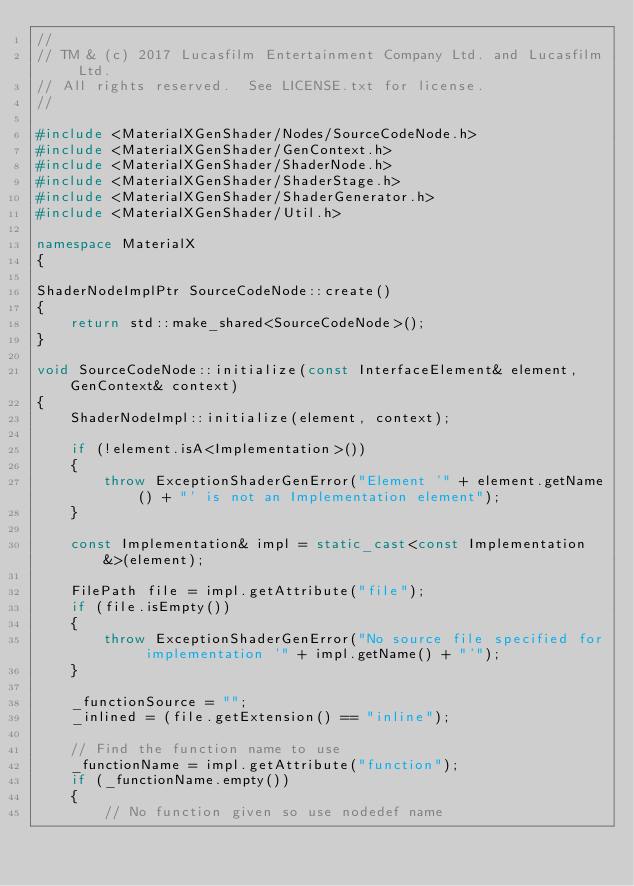<code> <loc_0><loc_0><loc_500><loc_500><_C++_>//
// TM & (c) 2017 Lucasfilm Entertainment Company Ltd. and Lucasfilm Ltd.
// All rights reserved.  See LICENSE.txt for license.
//

#include <MaterialXGenShader/Nodes/SourceCodeNode.h>
#include <MaterialXGenShader/GenContext.h>
#include <MaterialXGenShader/ShaderNode.h>
#include <MaterialXGenShader/ShaderStage.h>
#include <MaterialXGenShader/ShaderGenerator.h>
#include <MaterialXGenShader/Util.h>

namespace MaterialX
{

ShaderNodeImplPtr SourceCodeNode::create()
{
    return std::make_shared<SourceCodeNode>();
}

void SourceCodeNode::initialize(const InterfaceElement& element, GenContext& context)
{
    ShaderNodeImpl::initialize(element, context);

    if (!element.isA<Implementation>())
    {
        throw ExceptionShaderGenError("Element '" + element.getName() + "' is not an Implementation element");
    }

    const Implementation& impl = static_cast<const Implementation&>(element);

    FilePath file = impl.getAttribute("file");
    if (file.isEmpty())
    {
        throw ExceptionShaderGenError("No source file specified for implementation '" + impl.getName() + "'");
    }

    _functionSource = "";
    _inlined = (file.getExtension() == "inline");

    // Find the function name to use
    _functionName = impl.getAttribute("function");
    if (_functionName.empty())
    {
        // No function given so use nodedef name</code> 